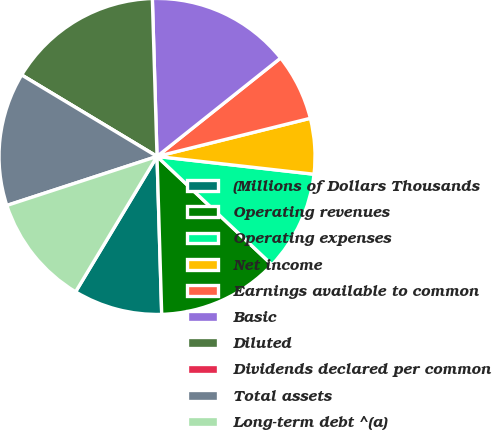Convert chart. <chart><loc_0><loc_0><loc_500><loc_500><pie_chart><fcel>(Millions of Dollars Thousands<fcel>Operating revenues<fcel>Operating expenses<fcel>Net income<fcel>Earnings available to common<fcel>Basic<fcel>Diluted<fcel>Dividends declared per common<fcel>Total assets<fcel>Long-term debt ^(a)<nl><fcel>9.09%<fcel>12.5%<fcel>10.23%<fcel>5.68%<fcel>6.82%<fcel>14.77%<fcel>15.91%<fcel>0.0%<fcel>13.64%<fcel>11.36%<nl></chart> 